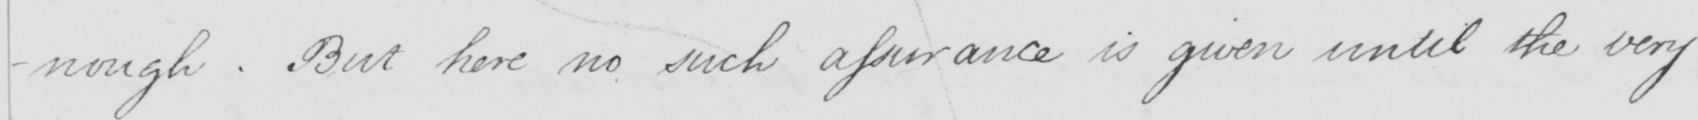Can you tell me what this handwritten text says? -nough . But here no such assurance is given until the very 